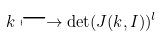<formula> <loc_0><loc_0><loc_500><loc_500>k \longmapsto \det ( J ( k , I ) ) ^ { l }</formula> 